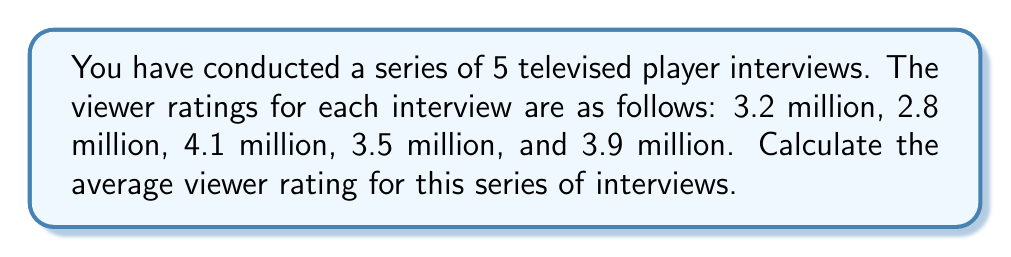Help me with this question. To calculate the average viewer rating, we need to follow these steps:

1. Sum up all the viewer ratings:
   $$3.2 + 2.8 + 4.1 + 3.5 + 3.9 = 17.5$$ million viewers

2. Count the total number of interviews:
   There are 5 interviews in the series.

3. Divide the sum of ratings by the number of interviews:
   $$\text{Average} = \frac{\text{Sum of ratings}}{\text{Number of interviews}} = \frac{17.5}{5} = 3.5$$ million viewers

Therefore, the average viewer rating for the series of televised interviews is 3.5 million viewers.
Answer: 3.5 million viewers 